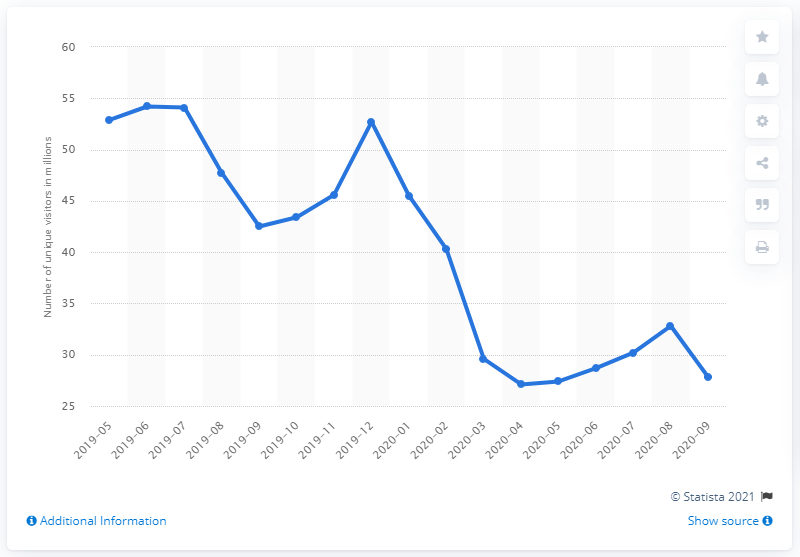Draw attention to some important aspects in this diagram. In February of 2020, approximately 40,300 unique global visitors visited Groupon, according to a unique visitor count. In May 2019, Groupon was visited by a total of 27.8 unique global visitors, according to the data available. 